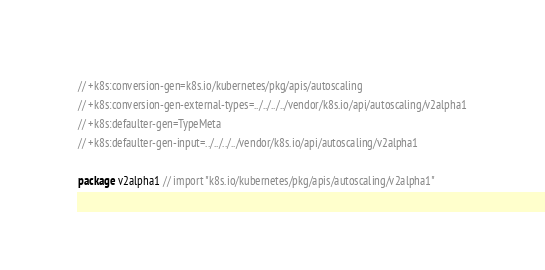Convert code to text. <code><loc_0><loc_0><loc_500><loc_500><_Go_>
// +k8s:conversion-gen=k8s.io/kubernetes/pkg/apis/autoscaling
// +k8s:conversion-gen-external-types=../../../../vendor/k8s.io/api/autoscaling/v2alpha1
// +k8s:defaulter-gen=TypeMeta
// +k8s:defaulter-gen-input=../../../../vendor/k8s.io/api/autoscaling/v2alpha1

package v2alpha1 // import "k8s.io/kubernetes/pkg/apis/autoscaling/v2alpha1"
</code> 